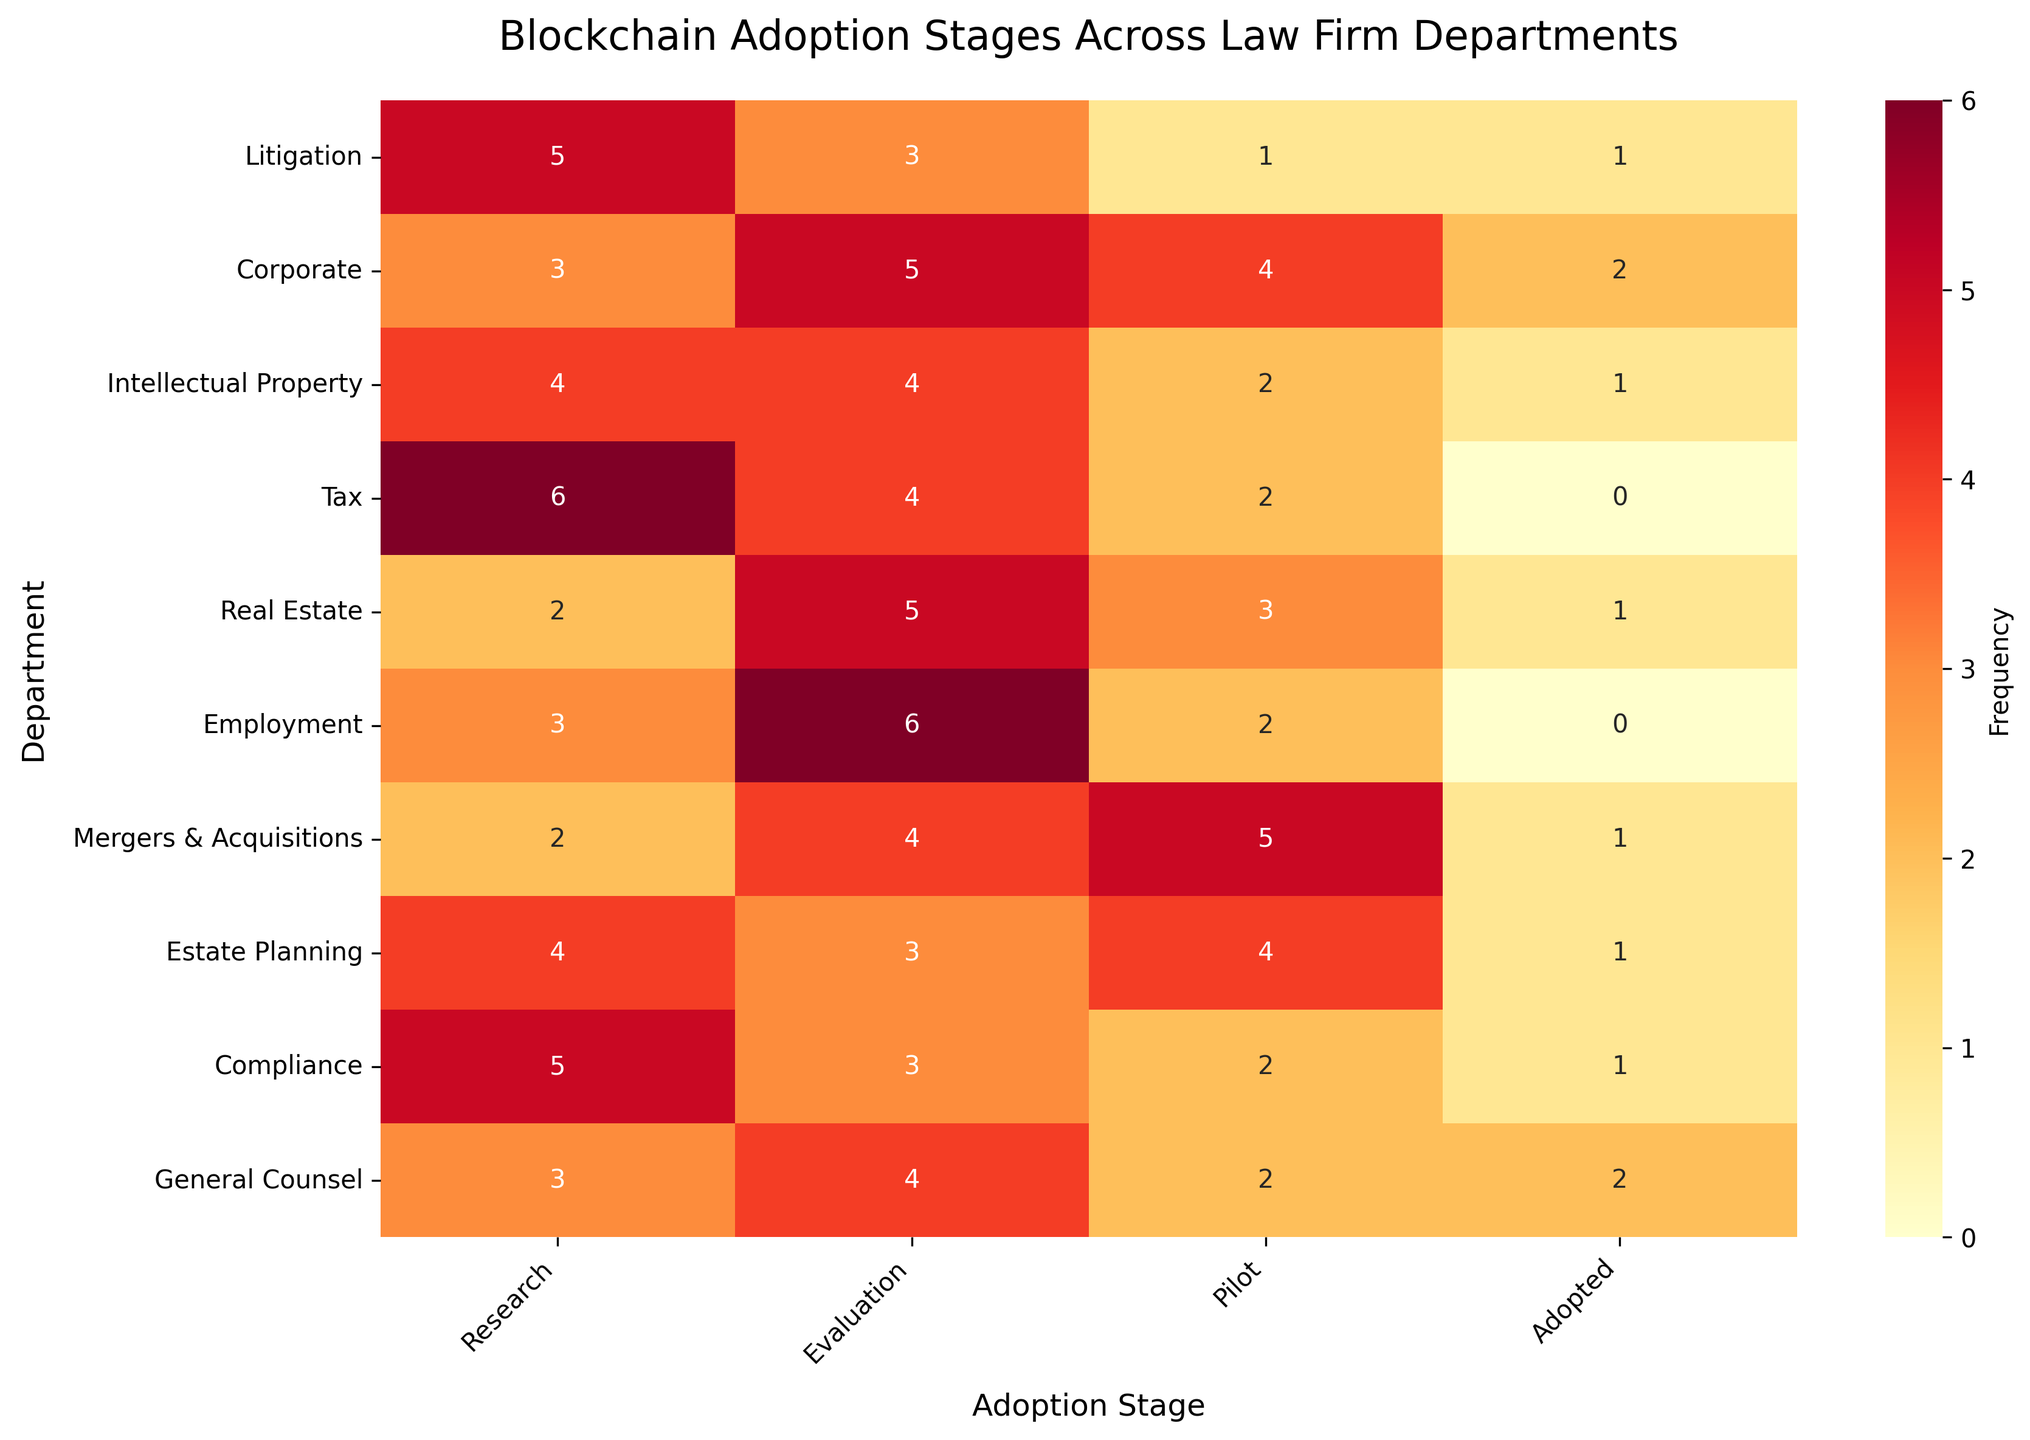Which department has the highest frequency of the 'Research' adoption stage? The department with the highest frequency in the 'Research' column has the highest count. By examining the heatmap, we can see that the Tax department has the highest frequency value of 6.
Answer: Tax Which department has the lowest frequency of the 'Adopted' stage? The department with the lowest frequency in the 'Adopted' column has the lowest count. By looking at the heatmap, we can see that the Tax and Employment departments have the lowest frequency of zero.
Answer: Tax and Employment What is the total frequency of the 'Pilot' stage across all departments? To find the total frequency of the 'Pilot' stage, sum the values in the 'Pilot' column: 1+4+2+2+3+2+5+4+2+2 = 27.
Answer: 27 Which two departments have an equal frequency of 5 in any adoption stage? By examining the heatmap, Corporate and Real Estate departments both have a frequency of 5 in the 'Evaluation' stage.
Answer: Corporate and Real Estate How many departments have a frequency of 3 in the 'Evaluation' stage? Count the number of departments that have a frequency of 3 in the 'Evaluation' column. From the heatmap, these departments are Litigation, Estate Planning, and Compliance.
Answer: 3 What is the average frequency of the 'Adopted' stage across all departments? Sum the frequencies of the 'Adopted' stage and then divide by the number of departments: (1+2+1+0+1+0+1+1+1+2)/10 = 1.
Answer: 1 Which department has the most balanced adoption stages? (i.e., least variation across stages) By examining the variation in frequency values per department, the General Counsel department has the values 3, 4, 2, 2, showing lesser deviation compared to other departments.
Answer: General Counsel What is the sum of frequencies for the Litigation department? Sum the values in the Litigation row: 5+3+1+1 = 10.
Answer: 10 